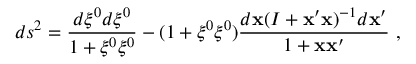<formula> <loc_0><loc_0><loc_500><loc_500>d s ^ { 2 } = \frac { d \xi ^ { 0 } d \xi ^ { 0 } } { 1 + \xi ^ { 0 } \xi ^ { 0 } } - ( 1 + \xi ^ { 0 } \xi ^ { 0 } ) \frac { d { x } ( I + { x } ^ { \prime } { x } ) ^ { - 1 } d { x } ^ { \prime } } { 1 + { x } { x } ^ { \prime } } ,</formula> 